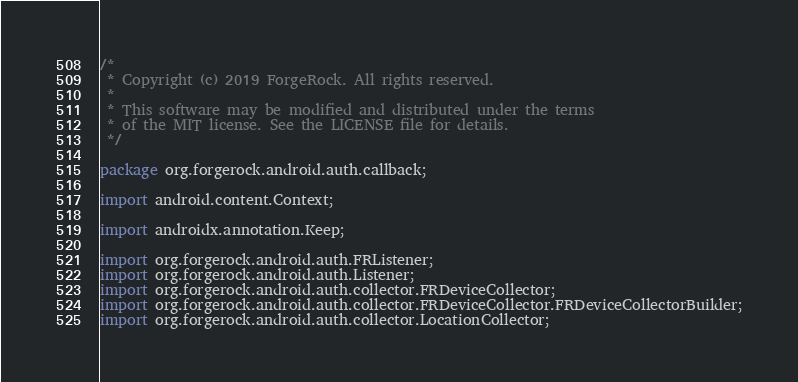Convert code to text. <code><loc_0><loc_0><loc_500><loc_500><_Java_>/*
 * Copyright (c) 2019 ForgeRock. All rights reserved.
 *
 * This software may be modified and distributed under the terms
 * of the MIT license. See the LICENSE file for details.
 */

package org.forgerock.android.auth.callback;

import android.content.Context;

import androidx.annotation.Keep;

import org.forgerock.android.auth.FRListener;
import org.forgerock.android.auth.Listener;
import org.forgerock.android.auth.collector.FRDeviceCollector;
import org.forgerock.android.auth.collector.FRDeviceCollector.FRDeviceCollectorBuilder;
import org.forgerock.android.auth.collector.LocationCollector;</code> 